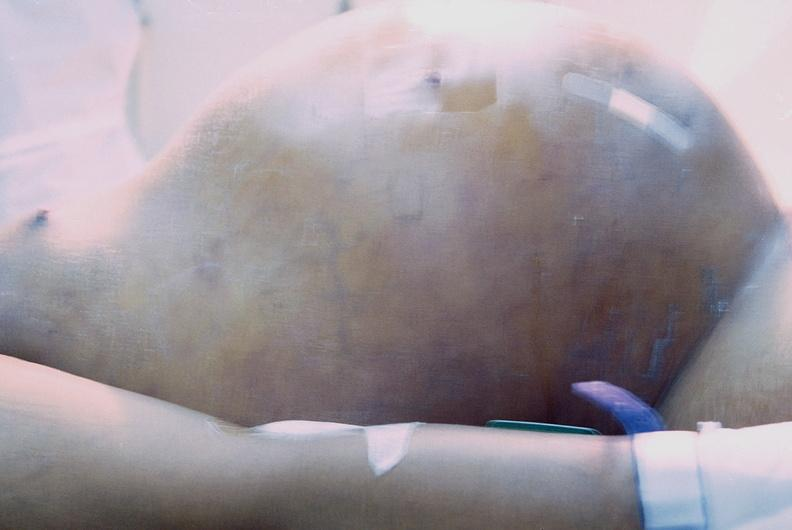what does this image show?
Answer the question using a single word or phrase. Ascites 